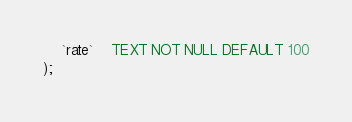Convert code to text. <code><loc_0><loc_0><loc_500><loc_500><_SQL_>	`rate`	TEXT NOT NULL DEFAULT 100
);
</code> 